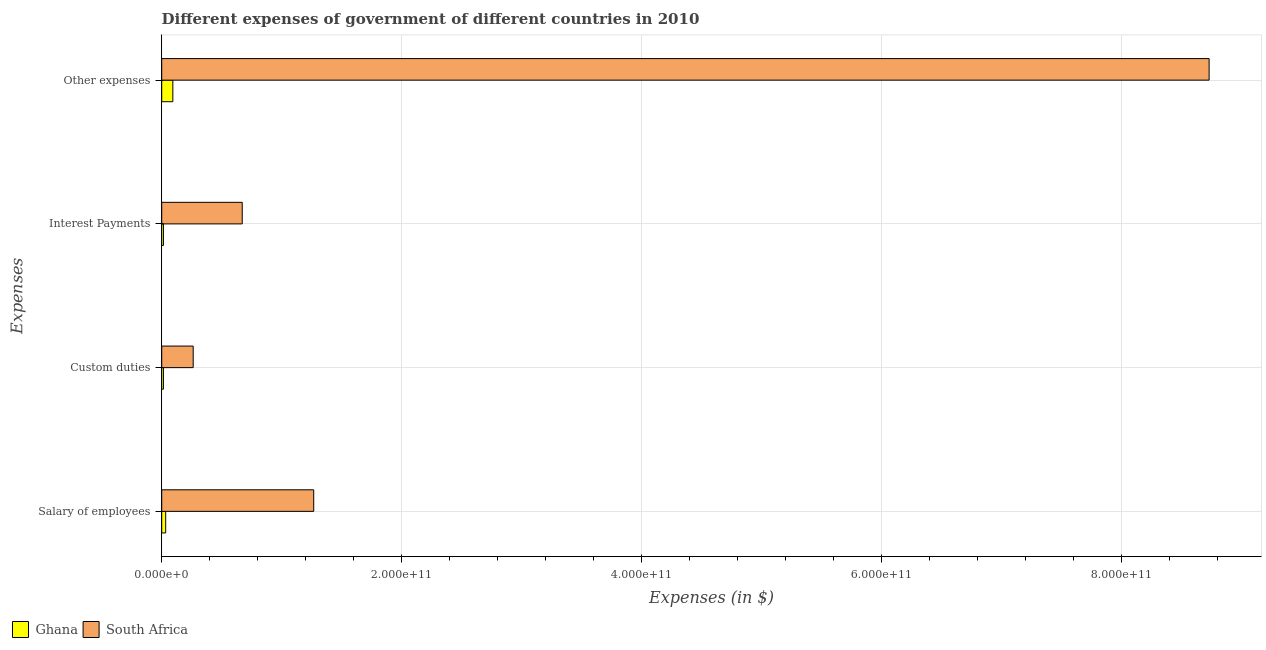How many different coloured bars are there?
Provide a succinct answer. 2. How many groups of bars are there?
Ensure brevity in your answer.  4. Are the number of bars per tick equal to the number of legend labels?
Give a very brief answer. Yes. How many bars are there on the 1st tick from the bottom?
Offer a very short reply. 2. What is the label of the 1st group of bars from the top?
Keep it short and to the point. Other expenses. What is the amount spent on interest payments in South Africa?
Your answer should be compact. 6.72e+1. Across all countries, what is the maximum amount spent on other expenses?
Make the answer very short. 8.73e+11. Across all countries, what is the minimum amount spent on salary of employees?
Your answer should be compact. 3.32e+09. In which country was the amount spent on other expenses maximum?
Make the answer very short. South Africa. What is the total amount spent on custom duties in the graph?
Provide a short and direct response. 2.77e+1. What is the difference between the amount spent on salary of employees in South Africa and that in Ghana?
Provide a succinct answer. 1.23e+11. What is the difference between the amount spent on salary of employees in South Africa and the amount spent on custom duties in Ghana?
Ensure brevity in your answer.  1.25e+11. What is the average amount spent on custom duties per country?
Keep it short and to the point. 1.38e+1. What is the difference between the amount spent on other expenses and amount spent on salary of employees in Ghana?
Provide a short and direct response. 5.97e+09. In how many countries, is the amount spent on salary of employees greater than 760000000000 $?
Give a very brief answer. 0. What is the ratio of the amount spent on salary of employees in South Africa to that in Ghana?
Your answer should be very brief. 38.23. Is the amount spent on custom duties in Ghana less than that in South Africa?
Your response must be concise. Yes. What is the difference between the highest and the second highest amount spent on salary of employees?
Provide a short and direct response. 1.23e+11. What is the difference between the highest and the lowest amount spent on other expenses?
Make the answer very short. 8.64e+11. Is the sum of the amount spent on salary of employees in Ghana and South Africa greater than the maximum amount spent on interest payments across all countries?
Offer a very short reply. Yes. Is it the case that in every country, the sum of the amount spent on custom duties and amount spent on salary of employees is greater than the sum of amount spent on interest payments and amount spent on other expenses?
Keep it short and to the point. No. What does the 2nd bar from the bottom in Salary of employees represents?
Make the answer very short. South Africa. Are all the bars in the graph horizontal?
Offer a terse response. Yes. How many countries are there in the graph?
Your response must be concise. 2. What is the difference between two consecutive major ticks on the X-axis?
Offer a terse response. 2.00e+11. Does the graph contain grids?
Your answer should be very brief. Yes. Where does the legend appear in the graph?
Make the answer very short. Bottom left. How are the legend labels stacked?
Your answer should be compact. Horizontal. What is the title of the graph?
Offer a very short reply. Different expenses of government of different countries in 2010. What is the label or title of the X-axis?
Provide a succinct answer. Expenses (in $). What is the label or title of the Y-axis?
Make the answer very short. Expenses. What is the Expenses (in $) in Ghana in Salary of employees?
Provide a short and direct response. 3.32e+09. What is the Expenses (in $) of South Africa in Salary of employees?
Ensure brevity in your answer.  1.27e+11. What is the Expenses (in $) in Ghana in Custom duties?
Provide a succinct answer. 1.44e+09. What is the Expenses (in $) in South Africa in Custom duties?
Your answer should be very brief. 2.62e+1. What is the Expenses (in $) of Ghana in Interest Payments?
Make the answer very short. 1.44e+09. What is the Expenses (in $) of South Africa in Interest Payments?
Make the answer very short. 6.72e+1. What is the Expenses (in $) in Ghana in Other expenses?
Keep it short and to the point. 9.28e+09. What is the Expenses (in $) of South Africa in Other expenses?
Make the answer very short. 8.73e+11. Across all Expenses, what is the maximum Expenses (in $) in Ghana?
Your response must be concise. 9.28e+09. Across all Expenses, what is the maximum Expenses (in $) of South Africa?
Give a very brief answer. 8.73e+11. Across all Expenses, what is the minimum Expenses (in $) of Ghana?
Make the answer very short. 1.44e+09. Across all Expenses, what is the minimum Expenses (in $) of South Africa?
Your answer should be very brief. 2.62e+1. What is the total Expenses (in $) in Ghana in the graph?
Your answer should be compact. 1.55e+1. What is the total Expenses (in $) of South Africa in the graph?
Provide a succinct answer. 1.09e+12. What is the difference between the Expenses (in $) of Ghana in Salary of employees and that in Custom duties?
Offer a very short reply. 1.88e+09. What is the difference between the Expenses (in $) of South Africa in Salary of employees and that in Custom duties?
Your answer should be compact. 1.01e+11. What is the difference between the Expenses (in $) in Ghana in Salary of employees and that in Interest Payments?
Ensure brevity in your answer.  1.88e+09. What is the difference between the Expenses (in $) in South Africa in Salary of employees and that in Interest Payments?
Offer a terse response. 5.96e+1. What is the difference between the Expenses (in $) of Ghana in Salary of employees and that in Other expenses?
Keep it short and to the point. -5.97e+09. What is the difference between the Expenses (in $) of South Africa in Salary of employees and that in Other expenses?
Offer a terse response. -7.47e+11. What is the difference between the Expenses (in $) of Ghana in Custom duties and that in Interest Payments?
Your answer should be very brief. -1.44e+06. What is the difference between the Expenses (in $) of South Africa in Custom duties and that in Interest Payments?
Ensure brevity in your answer.  -4.09e+1. What is the difference between the Expenses (in $) in Ghana in Custom duties and that in Other expenses?
Offer a terse response. -7.84e+09. What is the difference between the Expenses (in $) in South Africa in Custom duties and that in Other expenses?
Ensure brevity in your answer.  -8.47e+11. What is the difference between the Expenses (in $) in Ghana in Interest Payments and that in Other expenses?
Provide a succinct answer. -7.84e+09. What is the difference between the Expenses (in $) in South Africa in Interest Payments and that in Other expenses?
Your answer should be compact. -8.06e+11. What is the difference between the Expenses (in $) in Ghana in Salary of employees and the Expenses (in $) in South Africa in Custom duties?
Make the answer very short. -2.29e+1. What is the difference between the Expenses (in $) of Ghana in Salary of employees and the Expenses (in $) of South Africa in Interest Payments?
Your answer should be very brief. -6.38e+1. What is the difference between the Expenses (in $) in Ghana in Salary of employees and the Expenses (in $) in South Africa in Other expenses?
Offer a terse response. -8.70e+11. What is the difference between the Expenses (in $) of Ghana in Custom duties and the Expenses (in $) of South Africa in Interest Payments?
Make the answer very short. -6.57e+1. What is the difference between the Expenses (in $) of Ghana in Custom duties and the Expenses (in $) of South Africa in Other expenses?
Keep it short and to the point. -8.72e+11. What is the difference between the Expenses (in $) of Ghana in Interest Payments and the Expenses (in $) of South Africa in Other expenses?
Make the answer very short. -8.72e+11. What is the average Expenses (in $) of Ghana per Expenses?
Make the answer very short. 3.87e+09. What is the average Expenses (in $) in South Africa per Expenses?
Your response must be concise. 2.73e+11. What is the difference between the Expenses (in $) in Ghana and Expenses (in $) in South Africa in Salary of employees?
Your response must be concise. -1.23e+11. What is the difference between the Expenses (in $) of Ghana and Expenses (in $) of South Africa in Custom duties?
Provide a short and direct response. -2.48e+1. What is the difference between the Expenses (in $) of Ghana and Expenses (in $) of South Africa in Interest Payments?
Offer a very short reply. -6.57e+1. What is the difference between the Expenses (in $) in Ghana and Expenses (in $) in South Africa in Other expenses?
Make the answer very short. -8.64e+11. What is the ratio of the Expenses (in $) in Ghana in Salary of employees to that in Custom duties?
Give a very brief answer. 2.31. What is the ratio of the Expenses (in $) in South Africa in Salary of employees to that in Custom duties?
Provide a succinct answer. 4.83. What is the ratio of the Expenses (in $) of Ghana in Salary of employees to that in Interest Payments?
Give a very brief answer. 2.3. What is the ratio of the Expenses (in $) in South Africa in Salary of employees to that in Interest Payments?
Your response must be concise. 1.89. What is the ratio of the Expenses (in $) of Ghana in Salary of employees to that in Other expenses?
Give a very brief answer. 0.36. What is the ratio of the Expenses (in $) of South Africa in Salary of employees to that in Other expenses?
Keep it short and to the point. 0.15. What is the ratio of the Expenses (in $) of South Africa in Custom duties to that in Interest Payments?
Make the answer very short. 0.39. What is the ratio of the Expenses (in $) of Ghana in Custom duties to that in Other expenses?
Your response must be concise. 0.15. What is the ratio of the Expenses (in $) in South Africa in Custom duties to that in Other expenses?
Your answer should be very brief. 0.03. What is the ratio of the Expenses (in $) of Ghana in Interest Payments to that in Other expenses?
Provide a succinct answer. 0.16. What is the ratio of the Expenses (in $) in South Africa in Interest Payments to that in Other expenses?
Give a very brief answer. 0.08. What is the difference between the highest and the second highest Expenses (in $) of Ghana?
Offer a very short reply. 5.97e+09. What is the difference between the highest and the second highest Expenses (in $) of South Africa?
Your answer should be very brief. 7.47e+11. What is the difference between the highest and the lowest Expenses (in $) in Ghana?
Your response must be concise. 7.84e+09. What is the difference between the highest and the lowest Expenses (in $) of South Africa?
Make the answer very short. 8.47e+11. 